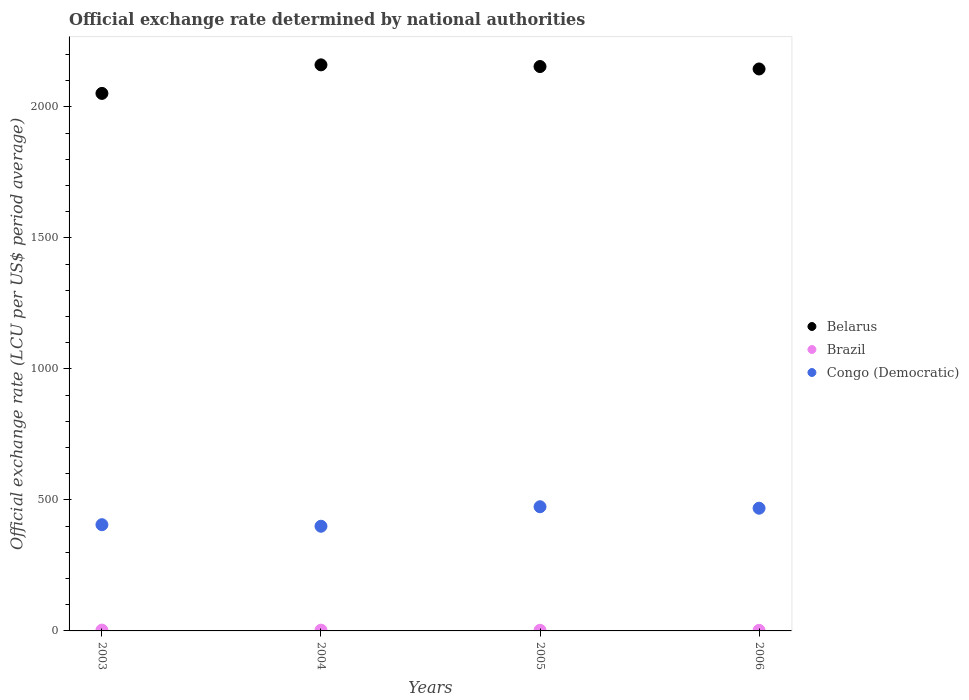How many different coloured dotlines are there?
Your answer should be very brief. 3. Is the number of dotlines equal to the number of legend labels?
Give a very brief answer. Yes. What is the official exchange rate in Belarus in 2006?
Your answer should be compact. 2144.56. Across all years, what is the maximum official exchange rate in Belarus?
Provide a short and direct response. 2160.26. Across all years, what is the minimum official exchange rate in Belarus?
Ensure brevity in your answer.  2051.27. In which year was the official exchange rate in Belarus minimum?
Provide a succinct answer. 2003. What is the total official exchange rate in Congo (Democratic) in the graph?
Give a very brief answer. 1747.06. What is the difference between the official exchange rate in Congo (Democratic) in 2004 and that in 2005?
Offer a very short reply. -74.43. What is the difference between the official exchange rate in Brazil in 2004 and the official exchange rate in Congo (Democratic) in 2005?
Make the answer very short. -470.98. What is the average official exchange rate in Belarus per year?
Ensure brevity in your answer.  2127.48. In the year 2003, what is the difference between the official exchange rate in Congo (Democratic) and official exchange rate in Belarus?
Your answer should be compact. -1645.87. What is the ratio of the official exchange rate in Belarus in 2003 to that in 2004?
Make the answer very short. 0.95. Is the official exchange rate in Belarus in 2005 less than that in 2006?
Keep it short and to the point. No. What is the difference between the highest and the second highest official exchange rate in Brazil?
Offer a very short reply. 0.15. What is the difference between the highest and the lowest official exchange rate in Congo (Democratic)?
Your answer should be compact. 74.43. In how many years, is the official exchange rate in Belarus greater than the average official exchange rate in Belarus taken over all years?
Ensure brevity in your answer.  3. Is the sum of the official exchange rate in Brazil in 2004 and 2006 greater than the maximum official exchange rate in Congo (Democratic) across all years?
Provide a succinct answer. No. Is it the case that in every year, the sum of the official exchange rate in Congo (Democratic) and official exchange rate in Brazil  is greater than the official exchange rate in Belarus?
Make the answer very short. No. Is the official exchange rate in Belarus strictly greater than the official exchange rate in Congo (Democratic) over the years?
Make the answer very short. Yes. Is the official exchange rate in Congo (Democratic) strictly less than the official exchange rate in Brazil over the years?
Your response must be concise. No. How many dotlines are there?
Keep it short and to the point. 3. Does the graph contain any zero values?
Make the answer very short. No. Does the graph contain grids?
Your response must be concise. No. How are the legend labels stacked?
Ensure brevity in your answer.  Vertical. What is the title of the graph?
Offer a very short reply. Official exchange rate determined by national authorities. What is the label or title of the X-axis?
Your response must be concise. Years. What is the label or title of the Y-axis?
Give a very brief answer. Official exchange rate (LCU per US$ period average). What is the Official exchange rate (LCU per US$ period average) in Belarus in 2003?
Provide a short and direct response. 2051.27. What is the Official exchange rate (LCU per US$ period average) in Brazil in 2003?
Offer a very short reply. 3.08. What is the Official exchange rate (LCU per US$ period average) in Congo (Democratic) in 2003?
Your answer should be compact. 405.4. What is the Official exchange rate (LCU per US$ period average) of Belarus in 2004?
Provide a short and direct response. 2160.26. What is the Official exchange rate (LCU per US$ period average) of Brazil in 2004?
Make the answer very short. 2.93. What is the Official exchange rate (LCU per US$ period average) of Congo (Democratic) in 2004?
Offer a terse response. 399.48. What is the Official exchange rate (LCU per US$ period average) in Belarus in 2005?
Your answer should be very brief. 2153.82. What is the Official exchange rate (LCU per US$ period average) in Brazil in 2005?
Ensure brevity in your answer.  2.43. What is the Official exchange rate (LCU per US$ period average) in Congo (Democratic) in 2005?
Ensure brevity in your answer.  473.91. What is the Official exchange rate (LCU per US$ period average) in Belarus in 2006?
Keep it short and to the point. 2144.56. What is the Official exchange rate (LCU per US$ period average) in Brazil in 2006?
Your answer should be compact. 2.18. What is the Official exchange rate (LCU per US$ period average) in Congo (Democratic) in 2006?
Provide a succinct answer. 468.28. Across all years, what is the maximum Official exchange rate (LCU per US$ period average) of Belarus?
Provide a short and direct response. 2160.26. Across all years, what is the maximum Official exchange rate (LCU per US$ period average) in Brazil?
Give a very brief answer. 3.08. Across all years, what is the maximum Official exchange rate (LCU per US$ period average) in Congo (Democratic)?
Your response must be concise. 473.91. Across all years, what is the minimum Official exchange rate (LCU per US$ period average) of Belarus?
Offer a very short reply. 2051.27. Across all years, what is the minimum Official exchange rate (LCU per US$ period average) of Brazil?
Give a very brief answer. 2.18. Across all years, what is the minimum Official exchange rate (LCU per US$ period average) in Congo (Democratic)?
Provide a succinct answer. 399.48. What is the total Official exchange rate (LCU per US$ period average) in Belarus in the graph?
Offer a very short reply. 8509.91. What is the total Official exchange rate (LCU per US$ period average) of Brazil in the graph?
Ensure brevity in your answer.  10.61. What is the total Official exchange rate (LCU per US$ period average) in Congo (Democratic) in the graph?
Offer a very short reply. 1747.06. What is the difference between the Official exchange rate (LCU per US$ period average) of Belarus in 2003 and that in 2004?
Provide a succinct answer. -108.99. What is the difference between the Official exchange rate (LCU per US$ period average) in Brazil in 2003 and that in 2004?
Give a very brief answer. 0.15. What is the difference between the Official exchange rate (LCU per US$ period average) in Congo (Democratic) in 2003 and that in 2004?
Ensure brevity in your answer.  5.92. What is the difference between the Official exchange rate (LCU per US$ period average) in Belarus in 2003 and that in 2005?
Offer a terse response. -102.55. What is the difference between the Official exchange rate (LCU per US$ period average) of Brazil in 2003 and that in 2005?
Offer a very short reply. 0.64. What is the difference between the Official exchange rate (LCU per US$ period average) of Congo (Democratic) in 2003 and that in 2005?
Offer a very short reply. -68.51. What is the difference between the Official exchange rate (LCU per US$ period average) of Belarus in 2003 and that in 2006?
Provide a short and direct response. -93.29. What is the difference between the Official exchange rate (LCU per US$ period average) of Brazil in 2003 and that in 2006?
Give a very brief answer. 0.9. What is the difference between the Official exchange rate (LCU per US$ period average) of Congo (Democratic) in 2003 and that in 2006?
Keep it short and to the point. -62.88. What is the difference between the Official exchange rate (LCU per US$ period average) of Belarus in 2004 and that in 2005?
Your answer should be very brief. 6.44. What is the difference between the Official exchange rate (LCU per US$ period average) of Brazil in 2004 and that in 2005?
Give a very brief answer. 0.49. What is the difference between the Official exchange rate (LCU per US$ period average) of Congo (Democratic) in 2004 and that in 2005?
Offer a terse response. -74.43. What is the difference between the Official exchange rate (LCU per US$ period average) in Belarus in 2004 and that in 2006?
Offer a terse response. 15.69. What is the difference between the Official exchange rate (LCU per US$ period average) in Brazil in 2004 and that in 2006?
Your answer should be very brief. 0.75. What is the difference between the Official exchange rate (LCU per US$ period average) of Congo (Democratic) in 2004 and that in 2006?
Offer a terse response. -68.8. What is the difference between the Official exchange rate (LCU per US$ period average) in Belarus in 2005 and that in 2006?
Offer a very short reply. 9.26. What is the difference between the Official exchange rate (LCU per US$ period average) in Brazil in 2005 and that in 2006?
Your response must be concise. 0.26. What is the difference between the Official exchange rate (LCU per US$ period average) in Congo (Democratic) in 2005 and that in 2006?
Your response must be concise. 5.63. What is the difference between the Official exchange rate (LCU per US$ period average) of Belarus in 2003 and the Official exchange rate (LCU per US$ period average) of Brazil in 2004?
Make the answer very short. 2048.35. What is the difference between the Official exchange rate (LCU per US$ period average) of Belarus in 2003 and the Official exchange rate (LCU per US$ period average) of Congo (Democratic) in 2004?
Offer a very short reply. 1651.8. What is the difference between the Official exchange rate (LCU per US$ period average) of Brazil in 2003 and the Official exchange rate (LCU per US$ period average) of Congo (Democratic) in 2004?
Keep it short and to the point. -396.4. What is the difference between the Official exchange rate (LCU per US$ period average) of Belarus in 2003 and the Official exchange rate (LCU per US$ period average) of Brazil in 2005?
Your answer should be compact. 2048.84. What is the difference between the Official exchange rate (LCU per US$ period average) in Belarus in 2003 and the Official exchange rate (LCU per US$ period average) in Congo (Democratic) in 2005?
Offer a very short reply. 1577.36. What is the difference between the Official exchange rate (LCU per US$ period average) in Brazil in 2003 and the Official exchange rate (LCU per US$ period average) in Congo (Democratic) in 2005?
Make the answer very short. -470.83. What is the difference between the Official exchange rate (LCU per US$ period average) in Belarus in 2003 and the Official exchange rate (LCU per US$ period average) in Brazil in 2006?
Make the answer very short. 2049.1. What is the difference between the Official exchange rate (LCU per US$ period average) of Belarus in 2003 and the Official exchange rate (LCU per US$ period average) of Congo (Democratic) in 2006?
Keep it short and to the point. 1582.99. What is the difference between the Official exchange rate (LCU per US$ period average) in Brazil in 2003 and the Official exchange rate (LCU per US$ period average) in Congo (Democratic) in 2006?
Ensure brevity in your answer.  -465.2. What is the difference between the Official exchange rate (LCU per US$ period average) in Belarus in 2004 and the Official exchange rate (LCU per US$ period average) in Brazil in 2005?
Ensure brevity in your answer.  2157.82. What is the difference between the Official exchange rate (LCU per US$ period average) of Belarus in 2004 and the Official exchange rate (LCU per US$ period average) of Congo (Democratic) in 2005?
Give a very brief answer. 1686.35. What is the difference between the Official exchange rate (LCU per US$ period average) in Brazil in 2004 and the Official exchange rate (LCU per US$ period average) in Congo (Democratic) in 2005?
Provide a succinct answer. -470.98. What is the difference between the Official exchange rate (LCU per US$ period average) in Belarus in 2004 and the Official exchange rate (LCU per US$ period average) in Brazil in 2006?
Give a very brief answer. 2158.08. What is the difference between the Official exchange rate (LCU per US$ period average) of Belarus in 2004 and the Official exchange rate (LCU per US$ period average) of Congo (Democratic) in 2006?
Ensure brevity in your answer.  1691.98. What is the difference between the Official exchange rate (LCU per US$ period average) of Brazil in 2004 and the Official exchange rate (LCU per US$ period average) of Congo (Democratic) in 2006?
Offer a terse response. -465.35. What is the difference between the Official exchange rate (LCU per US$ period average) in Belarus in 2005 and the Official exchange rate (LCU per US$ period average) in Brazil in 2006?
Offer a terse response. 2151.64. What is the difference between the Official exchange rate (LCU per US$ period average) of Belarus in 2005 and the Official exchange rate (LCU per US$ period average) of Congo (Democratic) in 2006?
Provide a succinct answer. 1685.54. What is the difference between the Official exchange rate (LCU per US$ period average) in Brazil in 2005 and the Official exchange rate (LCU per US$ period average) in Congo (Democratic) in 2006?
Your response must be concise. -465.84. What is the average Official exchange rate (LCU per US$ period average) of Belarus per year?
Your answer should be very brief. 2127.48. What is the average Official exchange rate (LCU per US$ period average) in Brazil per year?
Offer a very short reply. 2.65. What is the average Official exchange rate (LCU per US$ period average) in Congo (Democratic) per year?
Your answer should be compact. 436.76. In the year 2003, what is the difference between the Official exchange rate (LCU per US$ period average) of Belarus and Official exchange rate (LCU per US$ period average) of Brazil?
Your response must be concise. 2048.19. In the year 2003, what is the difference between the Official exchange rate (LCU per US$ period average) in Belarus and Official exchange rate (LCU per US$ period average) in Congo (Democratic)?
Your response must be concise. 1645.87. In the year 2003, what is the difference between the Official exchange rate (LCU per US$ period average) of Brazil and Official exchange rate (LCU per US$ period average) of Congo (Democratic)?
Your response must be concise. -402.32. In the year 2004, what is the difference between the Official exchange rate (LCU per US$ period average) of Belarus and Official exchange rate (LCU per US$ period average) of Brazil?
Keep it short and to the point. 2157.33. In the year 2004, what is the difference between the Official exchange rate (LCU per US$ period average) in Belarus and Official exchange rate (LCU per US$ period average) in Congo (Democratic)?
Your response must be concise. 1760.78. In the year 2004, what is the difference between the Official exchange rate (LCU per US$ period average) in Brazil and Official exchange rate (LCU per US$ period average) in Congo (Democratic)?
Your answer should be compact. -396.55. In the year 2005, what is the difference between the Official exchange rate (LCU per US$ period average) of Belarus and Official exchange rate (LCU per US$ period average) of Brazil?
Give a very brief answer. 2151.39. In the year 2005, what is the difference between the Official exchange rate (LCU per US$ period average) of Belarus and Official exchange rate (LCU per US$ period average) of Congo (Democratic)?
Your answer should be very brief. 1679.91. In the year 2005, what is the difference between the Official exchange rate (LCU per US$ period average) in Brazil and Official exchange rate (LCU per US$ period average) in Congo (Democratic)?
Your answer should be very brief. -471.47. In the year 2006, what is the difference between the Official exchange rate (LCU per US$ period average) in Belarus and Official exchange rate (LCU per US$ period average) in Brazil?
Keep it short and to the point. 2142.39. In the year 2006, what is the difference between the Official exchange rate (LCU per US$ period average) of Belarus and Official exchange rate (LCU per US$ period average) of Congo (Democratic)?
Make the answer very short. 1676.29. In the year 2006, what is the difference between the Official exchange rate (LCU per US$ period average) of Brazil and Official exchange rate (LCU per US$ period average) of Congo (Democratic)?
Provide a succinct answer. -466.1. What is the ratio of the Official exchange rate (LCU per US$ period average) of Belarus in 2003 to that in 2004?
Your response must be concise. 0.95. What is the ratio of the Official exchange rate (LCU per US$ period average) of Brazil in 2003 to that in 2004?
Keep it short and to the point. 1.05. What is the ratio of the Official exchange rate (LCU per US$ period average) of Congo (Democratic) in 2003 to that in 2004?
Provide a short and direct response. 1.01. What is the ratio of the Official exchange rate (LCU per US$ period average) in Brazil in 2003 to that in 2005?
Provide a short and direct response. 1.26. What is the ratio of the Official exchange rate (LCU per US$ period average) of Congo (Democratic) in 2003 to that in 2005?
Give a very brief answer. 0.86. What is the ratio of the Official exchange rate (LCU per US$ period average) of Belarus in 2003 to that in 2006?
Give a very brief answer. 0.96. What is the ratio of the Official exchange rate (LCU per US$ period average) in Brazil in 2003 to that in 2006?
Give a very brief answer. 1.41. What is the ratio of the Official exchange rate (LCU per US$ period average) of Congo (Democratic) in 2003 to that in 2006?
Ensure brevity in your answer.  0.87. What is the ratio of the Official exchange rate (LCU per US$ period average) in Belarus in 2004 to that in 2005?
Provide a succinct answer. 1. What is the ratio of the Official exchange rate (LCU per US$ period average) of Brazil in 2004 to that in 2005?
Provide a short and direct response. 1.2. What is the ratio of the Official exchange rate (LCU per US$ period average) in Congo (Democratic) in 2004 to that in 2005?
Provide a short and direct response. 0.84. What is the ratio of the Official exchange rate (LCU per US$ period average) of Belarus in 2004 to that in 2006?
Ensure brevity in your answer.  1.01. What is the ratio of the Official exchange rate (LCU per US$ period average) of Brazil in 2004 to that in 2006?
Your answer should be compact. 1.34. What is the ratio of the Official exchange rate (LCU per US$ period average) of Congo (Democratic) in 2004 to that in 2006?
Provide a succinct answer. 0.85. What is the ratio of the Official exchange rate (LCU per US$ period average) in Belarus in 2005 to that in 2006?
Your response must be concise. 1. What is the ratio of the Official exchange rate (LCU per US$ period average) of Brazil in 2005 to that in 2006?
Provide a succinct answer. 1.12. What is the ratio of the Official exchange rate (LCU per US$ period average) of Congo (Democratic) in 2005 to that in 2006?
Offer a very short reply. 1.01. What is the difference between the highest and the second highest Official exchange rate (LCU per US$ period average) in Belarus?
Offer a very short reply. 6.44. What is the difference between the highest and the second highest Official exchange rate (LCU per US$ period average) of Brazil?
Your answer should be compact. 0.15. What is the difference between the highest and the second highest Official exchange rate (LCU per US$ period average) in Congo (Democratic)?
Keep it short and to the point. 5.63. What is the difference between the highest and the lowest Official exchange rate (LCU per US$ period average) in Belarus?
Your response must be concise. 108.99. What is the difference between the highest and the lowest Official exchange rate (LCU per US$ period average) in Brazil?
Provide a succinct answer. 0.9. What is the difference between the highest and the lowest Official exchange rate (LCU per US$ period average) in Congo (Democratic)?
Provide a succinct answer. 74.43. 